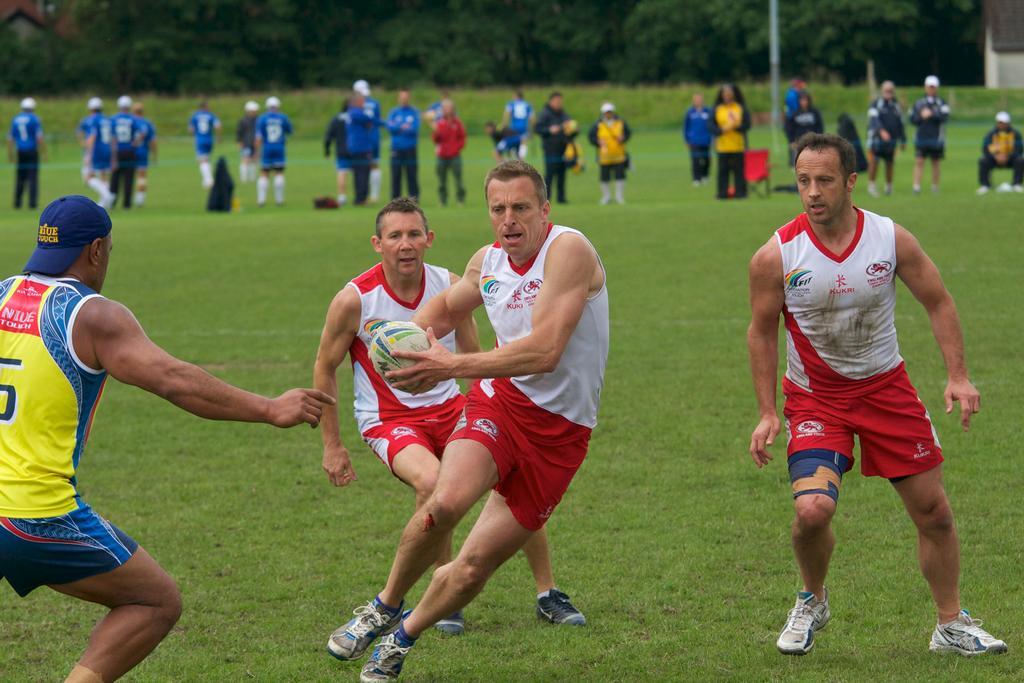In one or two sentences, can you explain what this image depicts? In this picture I can see few players playing with a ball and I can see few people standing in the back and I can see grass on the ground and few trees in the back. 